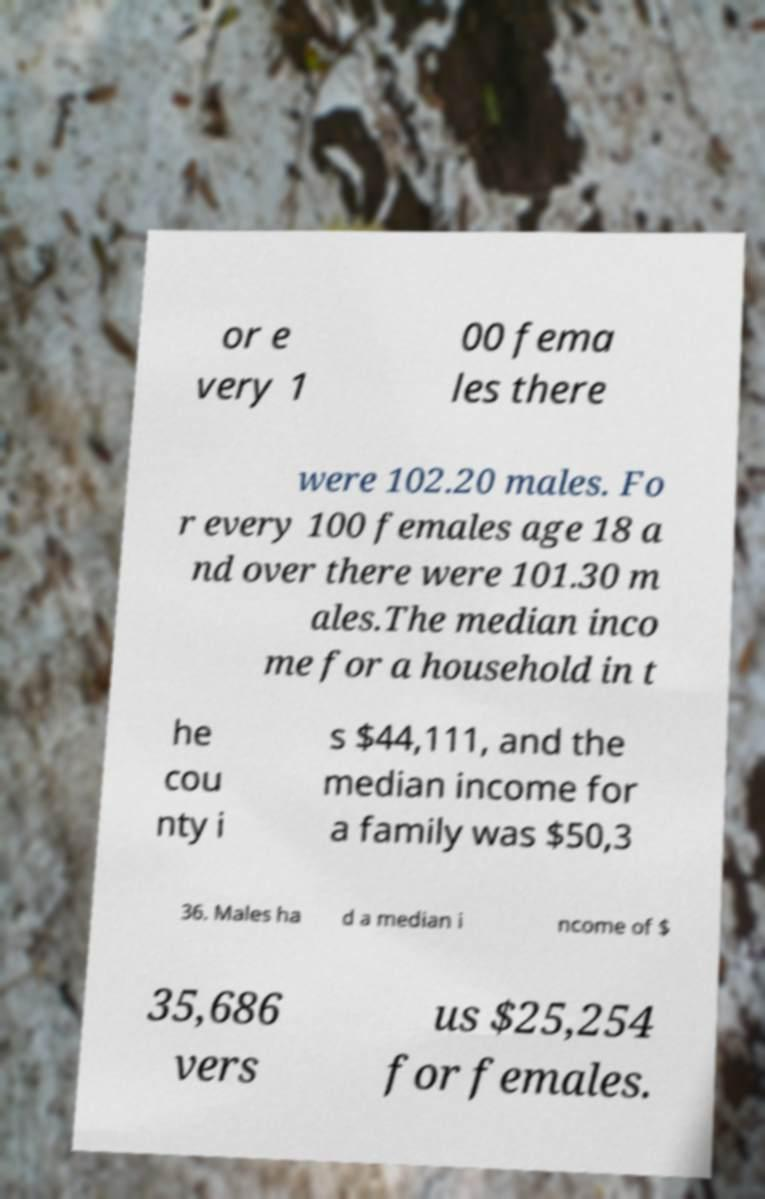Could you extract and type out the text from this image? or e very 1 00 fema les there were 102.20 males. Fo r every 100 females age 18 a nd over there were 101.30 m ales.The median inco me for a household in t he cou nty i s $44,111, and the median income for a family was $50,3 36. Males ha d a median i ncome of $ 35,686 vers us $25,254 for females. 